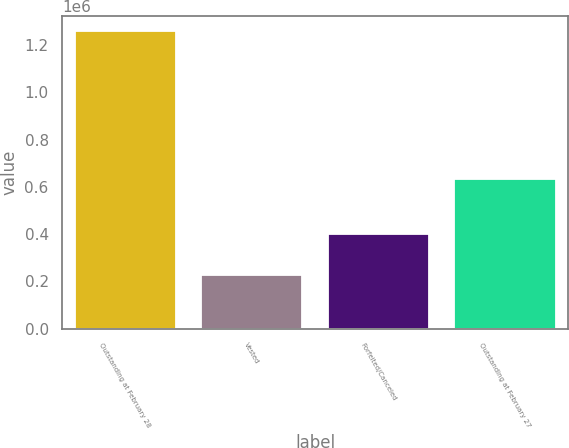Convert chart to OTSL. <chart><loc_0><loc_0><loc_500><loc_500><bar_chart><fcel>Outstanding at February 28<fcel>Vested<fcel>Forfeited/Canceled<fcel>Outstanding at February 27<nl><fcel>1.26e+06<fcel>226000<fcel>401000<fcel>633000<nl></chart> 